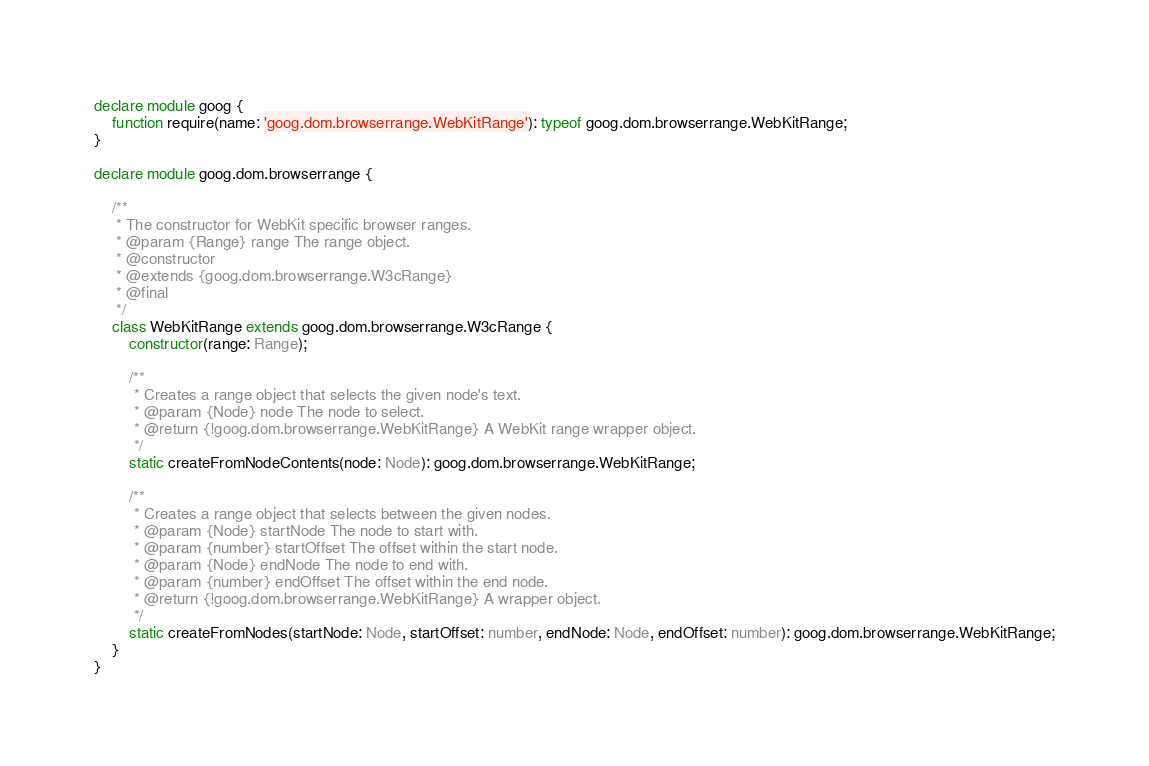<code> <loc_0><loc_0><loc_500><loc_500><_TypeScript_>declare module goog {
    function require(name: 'goog.dom.browserrange.WebKitRange'): typeof goog.dom.browserrange.WebKitRange;
}

declare module goog.dom.browserrange {

    /**
     * The constructor for WebKit specific browser ranges.
     * @param {Range} range The range object.
     * @constructor
     * @extends {goog.dom.browserrange.W3cRange}
     * @final
     */
    class WebKitRange extends goog.dom.browserrange.W3cRange {
        constructor(range: Range);
        
        /**
         * Creates a range object that selects the given node's text.
         * @param {Node} node The node to select.
         * @return {!goog.dom.browserrange.WebKitRange} A WebKit range wrapper object.
         */
        static createFromNodeContents(node: Node): goog.dom.browserrange.WebKitRange;
        
        /**
         * Creates a range object that selects between the given nodes.
         * @param {Node} startNode The node to start with.
         * @param {number} startOffset The offset within the start node.
         * @param {Node} endNode The node to end with.
         * @param {number} endOffset The offset within the end node.
         * @return {!goog.dom.browserrange.WebKitRange} A wrapper object.
         */
        static createFromNodes(startNode: Node, startOffset: number, endNode: Node, endOffset: number): goog.dom.browserrange.WebKitRange;
    }
}
</code> 